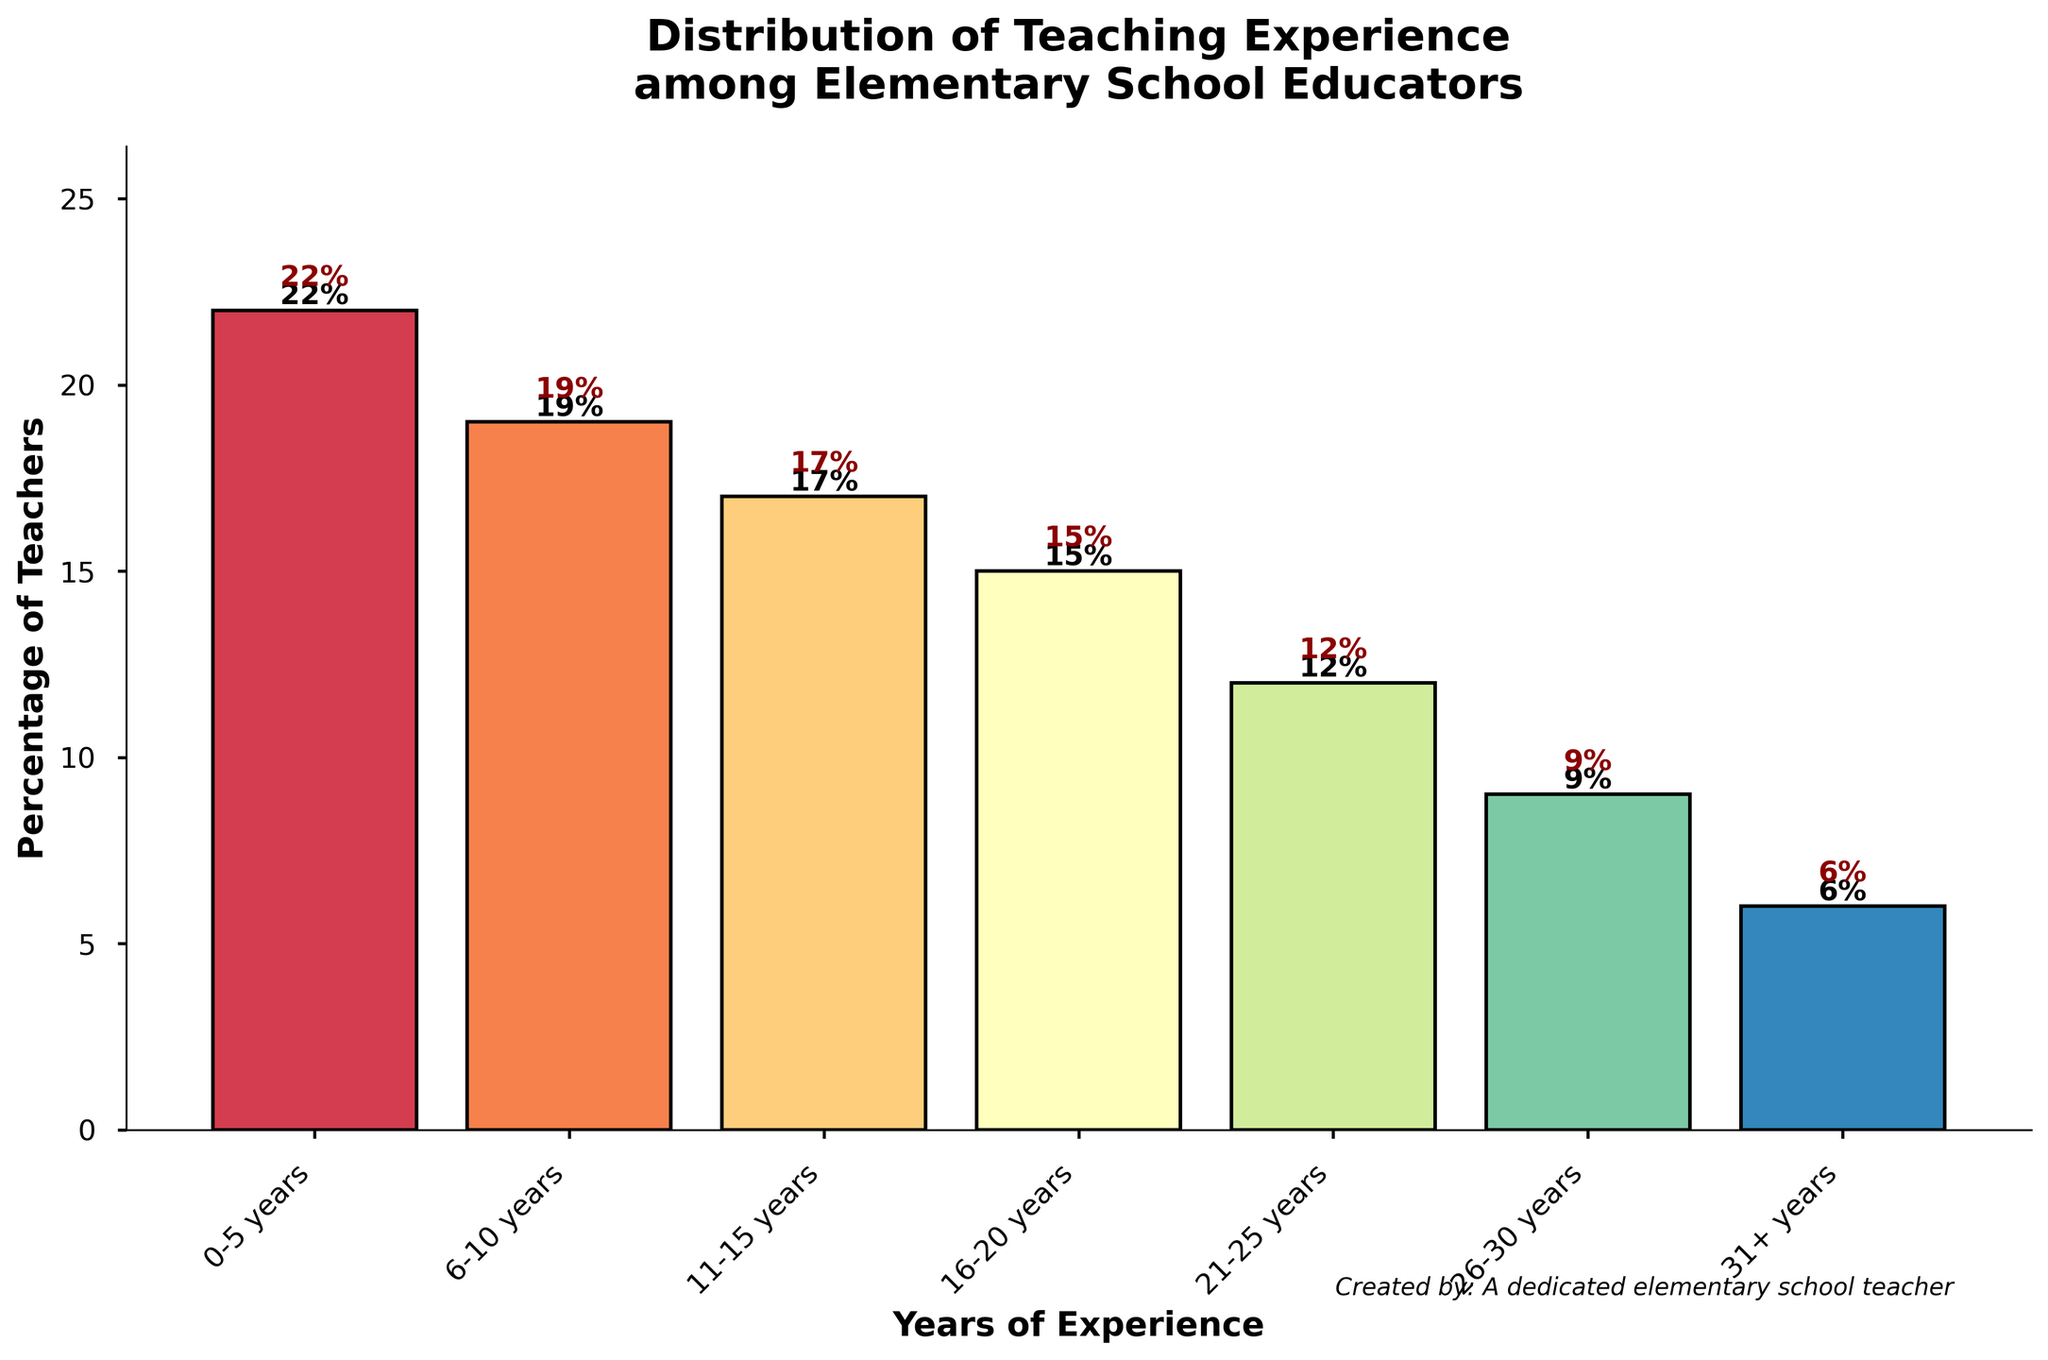What percentage of teachers have more than 20 years of experience? To find the percentage of teachers with more than 20 years of experience, we need to add the percentages of the categories "21-25 years," "26-30 years," and "31+ years": 12% + 9% + 6% = 27%.
Answer: 27% Which range of teaching experience has the highest percentage of teachers? By examining the heights of the bars, the "0-5 years" range is the tallest, indicating it has the highest percentage.
Answer: 0-5 years What is the difference in the percentage of teachers between the "0-5 years" and the "31+ years" experience categories? Calculate the difference by subtracting the percentage of the "31+ years" category from the "0-5 years" category: 22% - 6% = 16%.
Answer: 16% How many categories have a percentage of teachers above the overall average percentage? The total percentage equals 100%, and there are 7 categories, so the average percentage is 100%/7 ≈ 14.29%. The categories above this average are "0-5 years" (22%), "6-10 years" (19%), and "11-15 years" (17%). This totals 3 categories.
Answer: 3 What is the sum of the percentages of teachers with 6-15 years of experience? Add the percentages of the "6-10 years" and "11-15 years" categories: 19% + 17% = 36%.
Answer: 36% Is the percentage of teachers with 11-15 years of experience greater than the percentage of teachers with 26-30 years of experience? Compare the two percentages directly: 17% (11-15 years) > 9% (26-30 years).
Answer: Yes Which range of teaching experience has the smallest percentage of teachers? The shortest bar corresponds to the "31+ years" category, which has the smallest percentage.
Answer: 31+ years What is the visual difference in height between the bars for "0-5 years" and "16-20 years" categories? By observing the heights, "0-5 years" is clearly taller. The difference in percentages between these categories is 22% (0-5 years) - 15% (16-20 years) = 7%.
Answer: 7% Calculate the mean percentage of the "0-5 years," "6-10 years," and "11-15 years" categories. Sum these percentages and divide by the number of categories: (22% + 19% + 17%) / 3 = 58% / 3 ≈ 19.33%.
Answer: 19.33% 